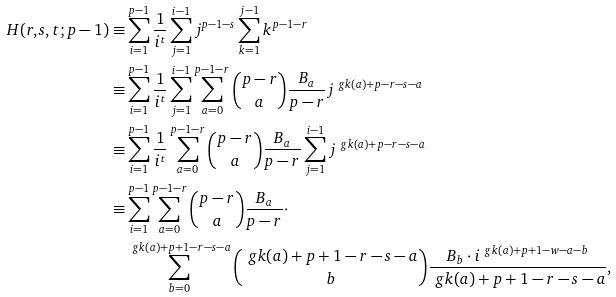<formula> <loc_0><loc_0><loc_500><loc_500>H ( r , s , t ; p - 1 ) \equiv & \sum _ { i = 1 } ^ { p - 1 } \frac { 1 } { i ^ { t } } \sum _ { j = 1 } ^ { i - 1 } j ^ { p - 1 - s } \sum _ { k = 1 } ^ { j - 1 } k ^ { p - 1 - r } \\ \equiv & \sum _ { i = 1 } ^ { p - 1 } \frac { 1 } { i ^ { t } } \sum _ { j = 1 } ^ { i - 1 } \sum _ { a = 0 } ^ { p - 1 - r } { p - r \choose a } \frac { B _ { a } } { p - r } j ^ { \ g k ( a ) + p - r - s - a } \\ \equiv & \sum _ { i = 1 } ^ { p - 1 } \frac { 1 } { i ^ { t } } \sum _ { a = 0 } ^ { p - 1 - r } { p - r \choose a } \frac { B _ { a } } { p - r } \sum _ { j = 1 } ^ { i - 1 } j ^ { \ g k ( a ) + p - r - s - a } \\ \equiv & \sum _ { i = 1 } ^ { p - 1 } \sum _ { a = 0 } ^ { p - 1 - r } { p - r \choose a } \frac { B _ { a } } { p - r } \cdot \\ \ & \sum _ { b = 0 } ^ { \ g k ( a ) + p + 1 - r - s - a } { \ g k ( a ) + p + 1 - r - s - a \choose b } \frac { B _ { b } \cdot i ^ { \ g k ( a ) + p + 1 - w - a - b } } { \ g k ( a ) + p + 1 - r - s - a } ,</formula> 